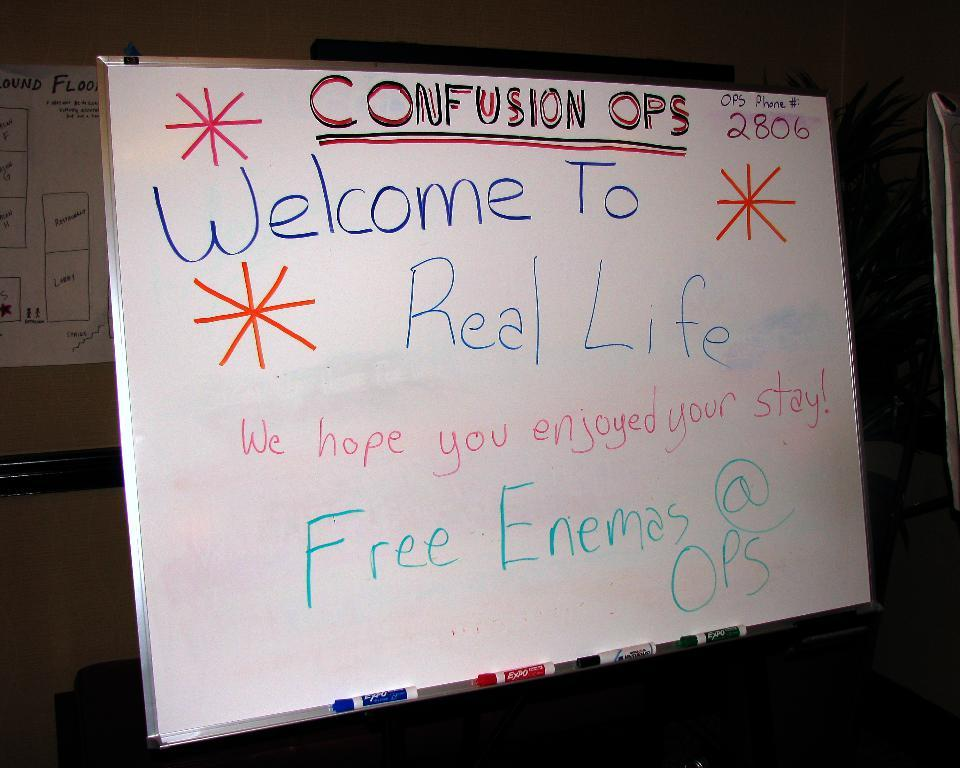<image>
Create a compact narrative representing the image presented. A marker board is displaying a welcome note. 